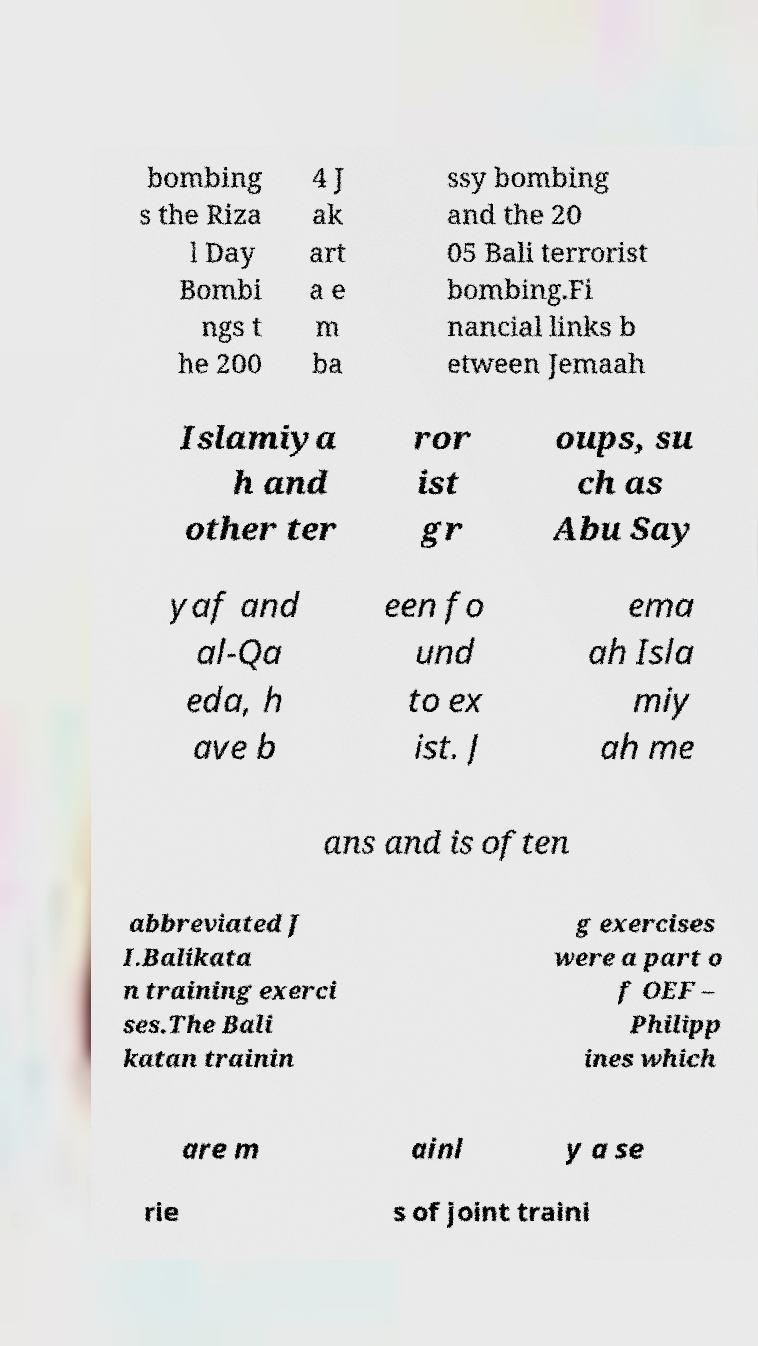I need the written content from this picture converted into text. Can you do that? bombing s the Riza l Day Bombi ngs t he 200 4 J ak art a e m ba ssy bombing and the 20 05 Bali terrorist bombing.Fi nancial links b etween Jemaah Islamiya h and other ter ror ist gr oups, su ch as Abu Say yaf and al-Qa eda, h ave b een fo und to ex ist. J ema ah Isla miy ah me ans and is often abbreviated J I.Balikata n training exerci ses.The Bali katan trainin g exercises were a part o f OEF – Philipp ines which are m ainl y a se rie s of joint traini 